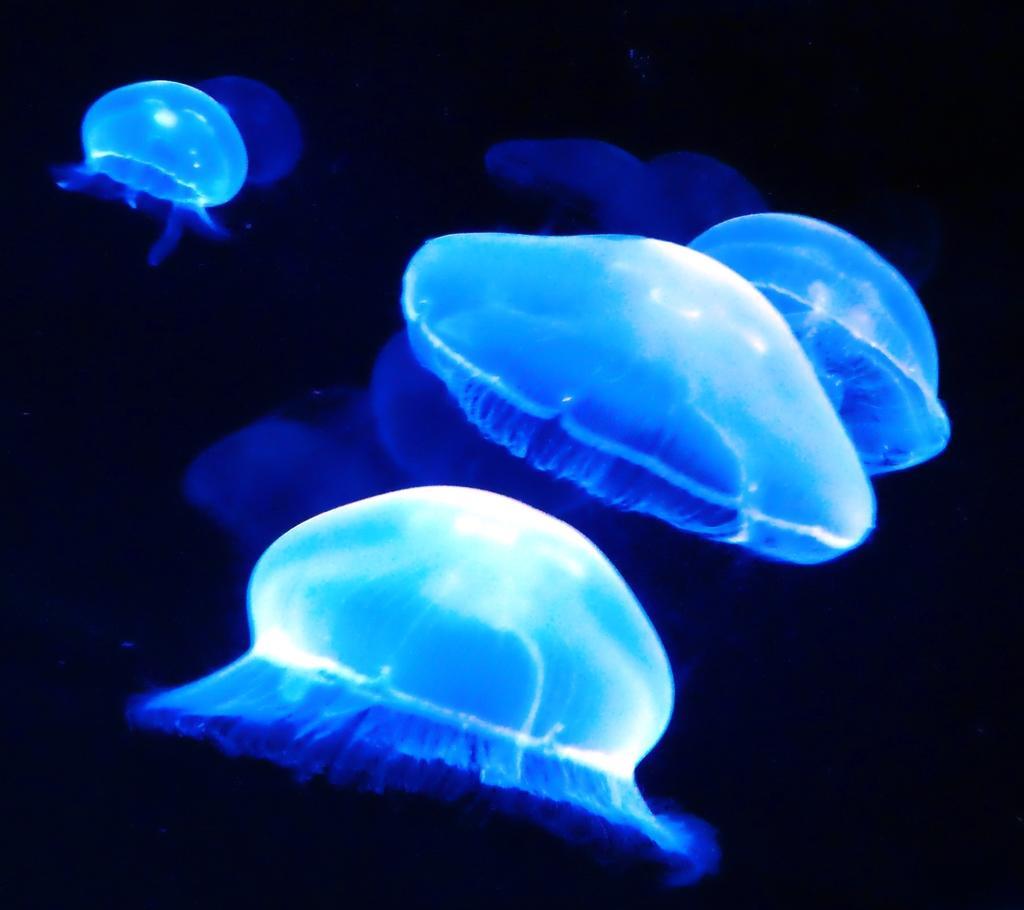Please provide a concise description of this image. In this picture, we see the jelly fishes which are in blue color. In the background, it is in black color. This picture might be clicked in the aquarium. 